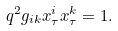<formula> <loc_0><loc_0><loc_500><loc_500>q ^ { 2 } g _ { i k } x ^ { i } _ { \tau } x ^ { k } _ { \tau } = 1 .</formula> 